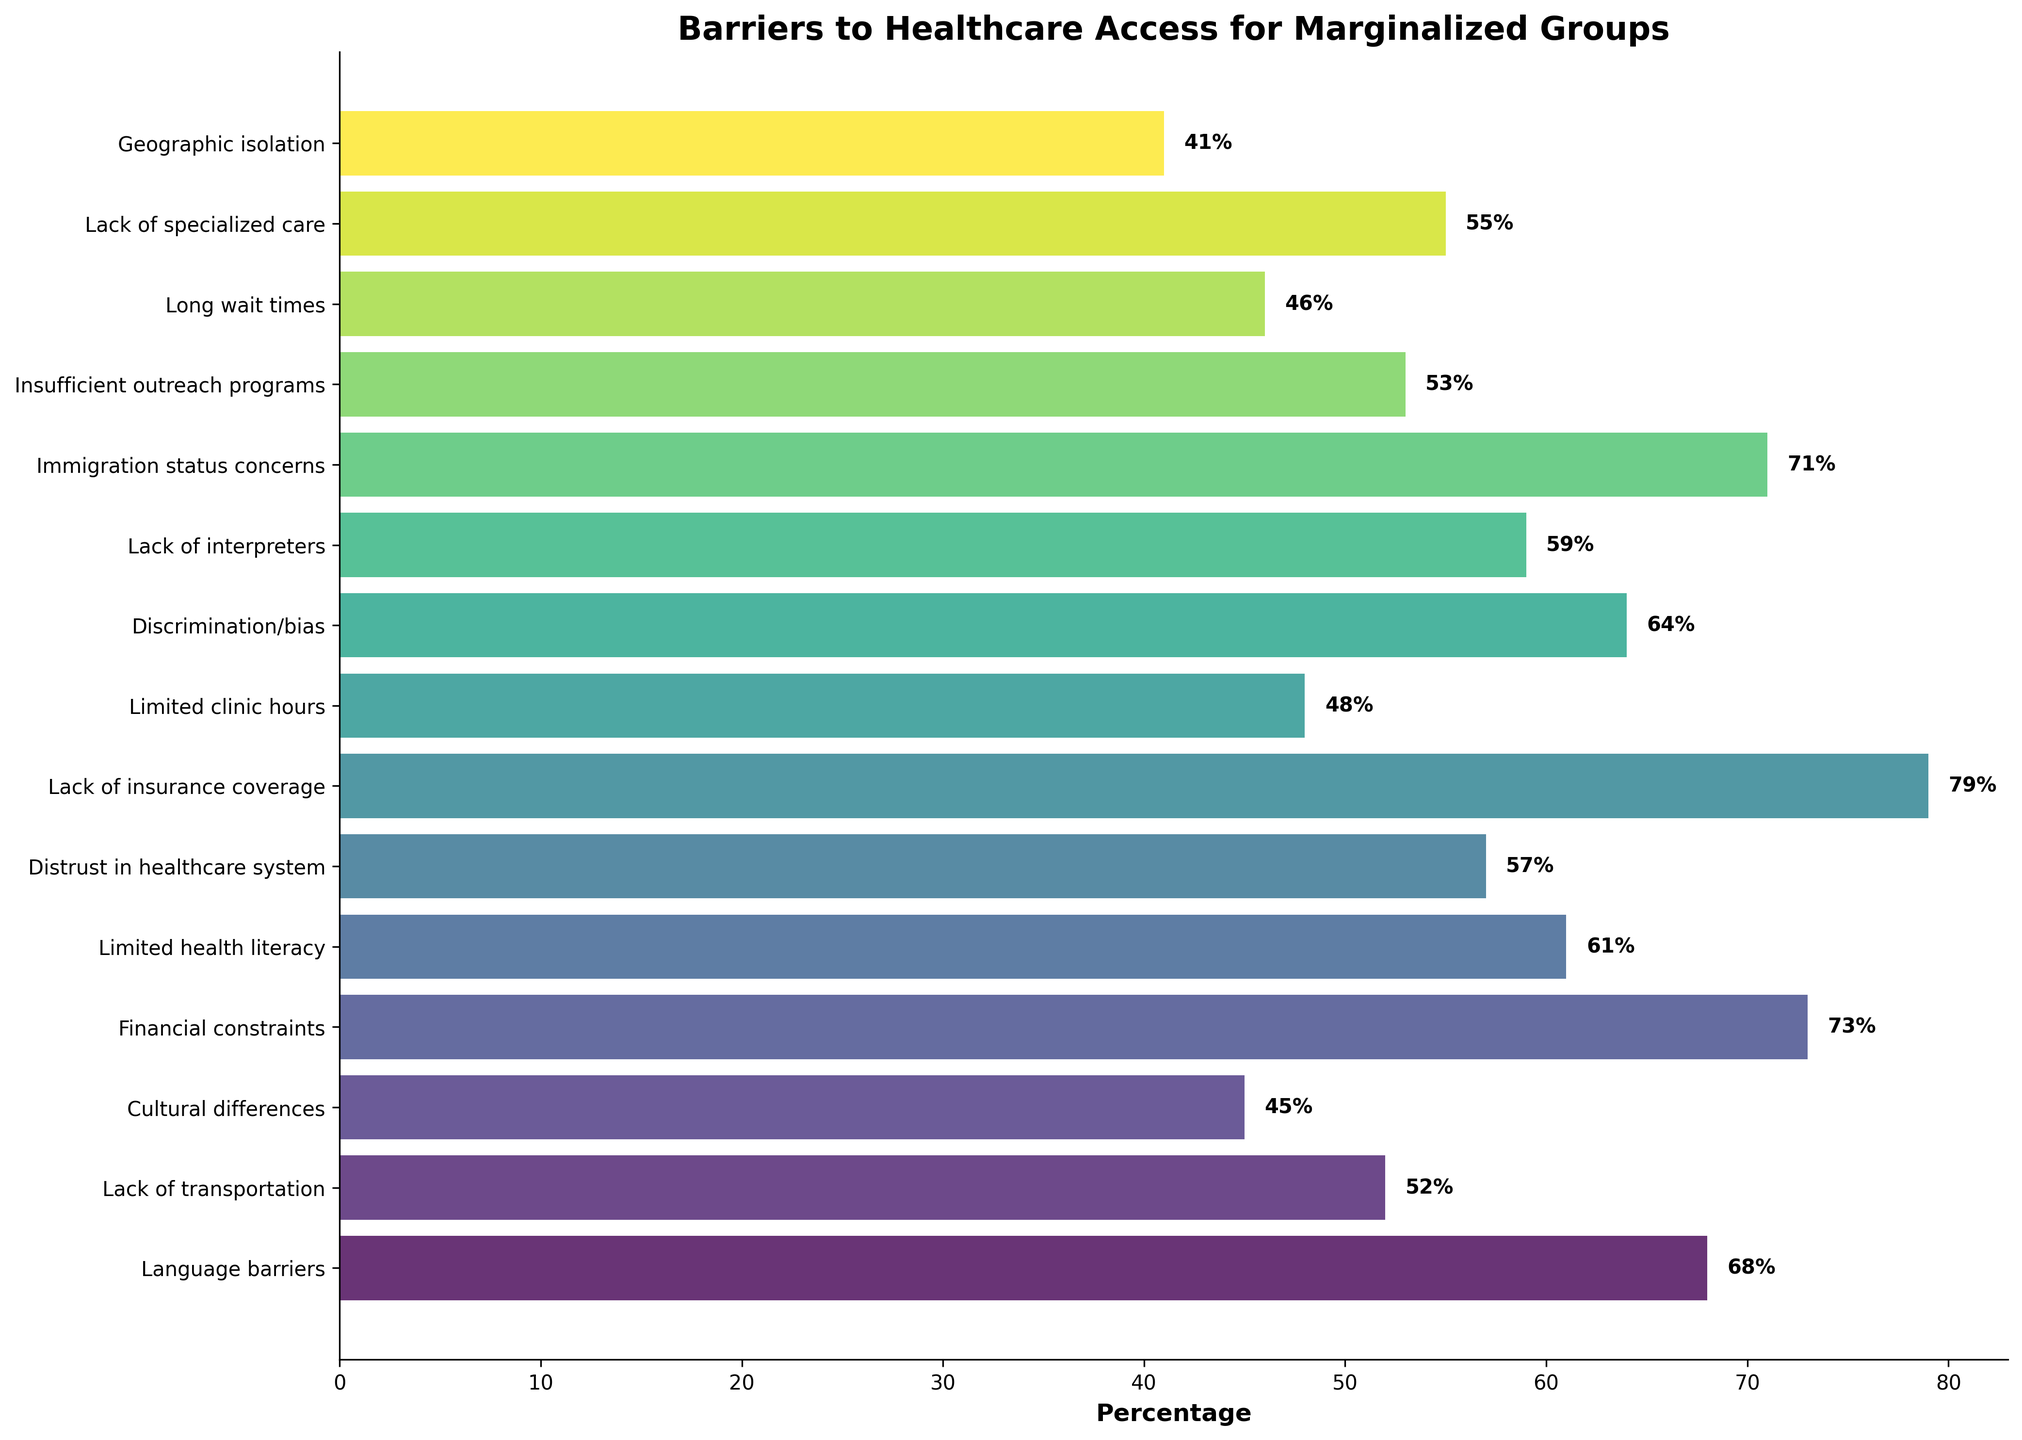What is the percentage for the group reporting 'Lack of insurance coverage'? To find the percentage for 'Lack of insurance coverage,' locate the corresponding bar next to this label and read the value displayed. The percentage is written directly on the bar in the figure.
Answer: 79% Which barrier has the lowest percentage? Identify the bar that is the shortest and check the label next to it. The label indicates 'Geographic isolation,' and the percentage value read from the bar is the lowest among all.
Answer: Geographic isolation Compare the 'Financial constraints' and 'Distrust in healthcare system' barriers. Which one has a higher percentage, and by how much? Locate the bars for 'Financial constraints' and 'Distrust in healthcare system' and read their corresponding percentages (73% and 57%, respectively). Subtract the lower percentage from the higher one: 73% - 57% = 16%.
Answer: Financial constraints, by 16% What is the average percentage of the 'Language barriers,' 'Cultural differences,' and 'Immigration status concerns' barriers? First, find and sum up the percentages for 'Language barriers' (68%), 'Cultural differences' (45%), and 'Immigration status concerns' (71%). The total is 68 + 45 + 71 = 184. Then divide by the number of items: 184 / 3 ≈ 61.33%.
Answer: 61.33% What is the difference in percentage between the highest barrier and the lowest barrier? Identify the highest percentage ('Lack of insurance coverage,' 79%) and the lowest percentage ('Geographic isolation,' 41%) from the bars. Subtract the lowest from the highest: 79% - 41% = 38%.
Answer: 38% Which barriers have a percentage greater than 60%? Look at the bars with percentages marked next to them and select those with values above 60%. These barriers are 'Language barriers' (68%), 'Financial constraints' (73%), 'Distrust in healthcare system' (57%), 'Discrimination/bias' (64%), 'Lack of interpreters' (59%), 'Immigration status concerns' (71%), and 'Lack of insurance coverage' (79%).
Answer: Language barriers, Financial constraints, Discrimination/bias, Immigration status concerns, Lack of insurance coverage What is the combined percentage of 'Limited health literacy,' 'Lack of interpreters,' and 'Long wait times'? Find and sum the percentages of 'Limited health literacy' (61%), 'Lack of interpreters' (59%), and 'Long wait times' (46%). The combined value is 61 + 59 + 46 = 166%.
Answer: 166% Which two barriers have nearly equal percentages, differing by no more than 3%? Observe all bars and compare their percentages, looking for values differing by 3% or less. 'Lack of interpreters' (59%) and 'Distrust in healthcare system' (57%) differ by just 2%.
Answer: Lack of interpreters and Distrust in healthcare system Which barrier with a percentage above 50% has the smallest percentage? List barriers with percentages above 50% and find the smallest among them. The relevant barriers are 'Language barriers' (68%), 'Lack of transportation' (52%), 'Financial constraints' (73%), 'Limited health literacy' (61%), 'Distrust in healthcare system' (57%), 'Lack of insurance coverage' (79%), 'Discrimination/bias' (64%), 'Lack of interpreters' (59%), and 'Immigration status concerns' (71%). 'Lack of transportation' has the smallest percentage among them at 52%.
Answer: Lack of transportation 